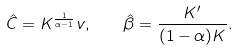<formula> <loc_0><loc_0><loc_500><loc_500>\hat { C } = K ^ { \frac { 1 } { \alpha - 1 } } v , \quad \hat { \beta } = \frac { K ^ { \prime } } { ( 1 - \alpha ) K } .</formula> 